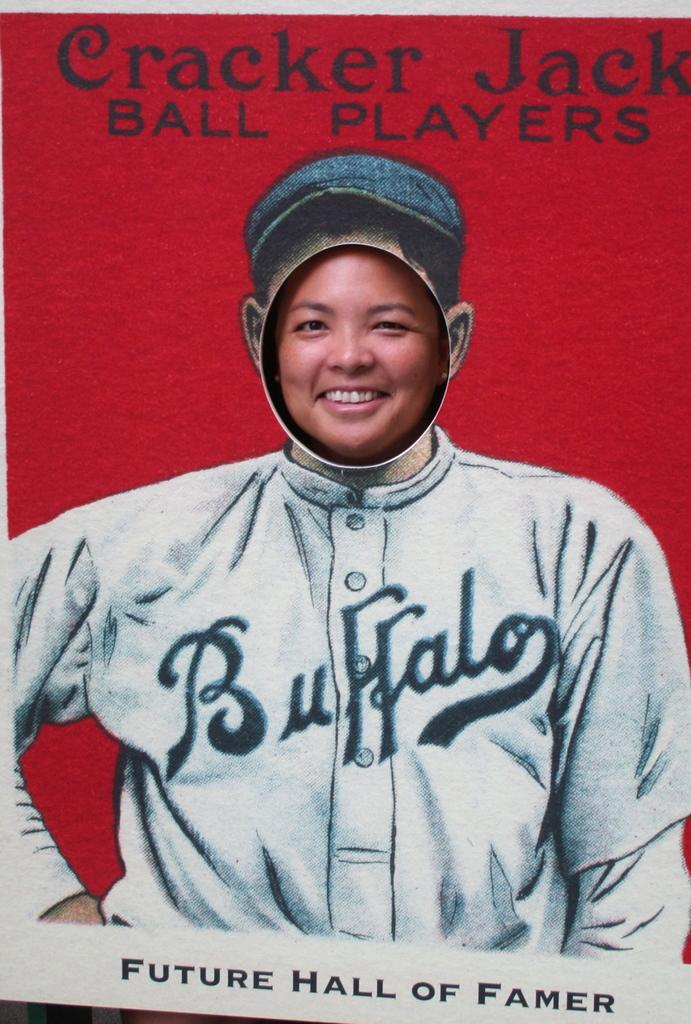<image>
Offer a succinct explanation of the picture presented. A woman taking a photo in a picture of a Buffalo baseball player. 